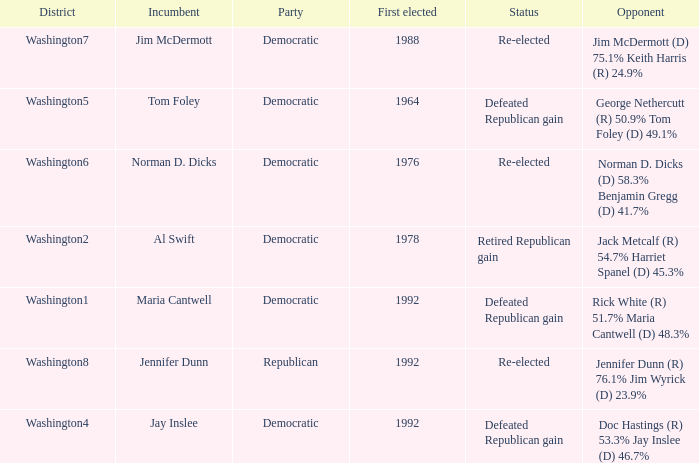What year was incumbent jim mcdermott first elected? 1988.0. 